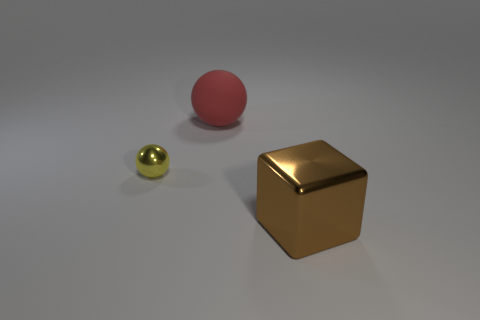Add 3 tiny yellow objects. How many objects exist? 6 Subtract all balls. How many objects are left? 1 Subtract 0 yellow cylinders. How many objects are left? 3 Subtract all tiny cyan metallic objects. Subtract all large cubes. How many objects are left? 2 Add 1 big red rubber spheres. How many big red rubber spheres are left? 2 Add 2 big red matte things. How many big red matte things exist? 3 